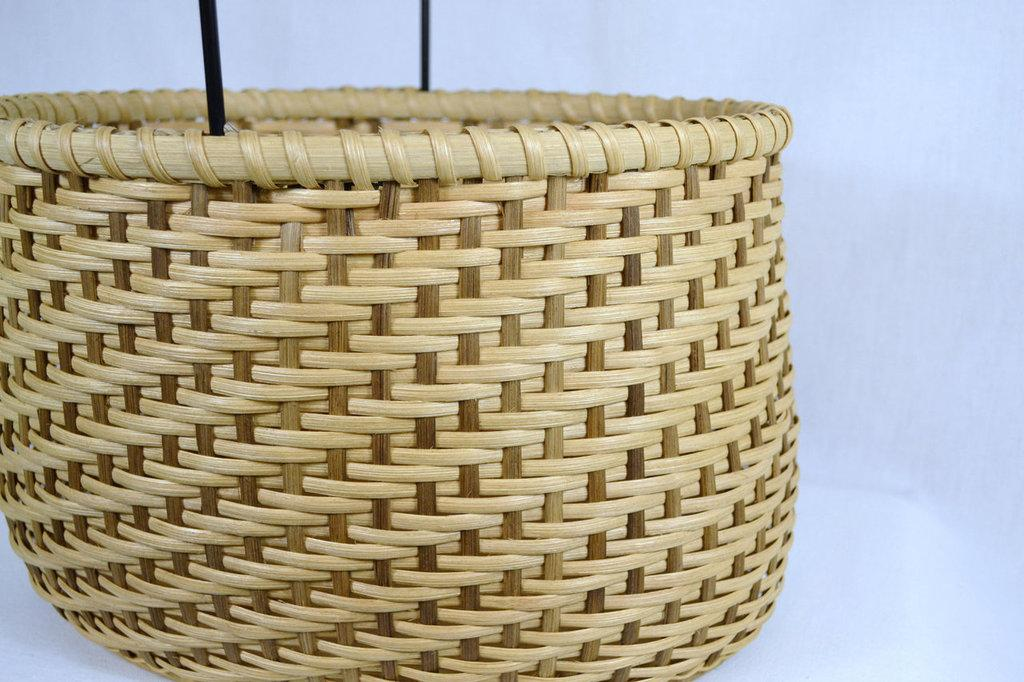What object made of wood can be seen in the image? There is a wooden basket in the image. What color is the background and bottom of the image? The background and bottom of the image are white. Can you see any kittens fighting in the image? There are no kittens or any fighting depicted in the image. 